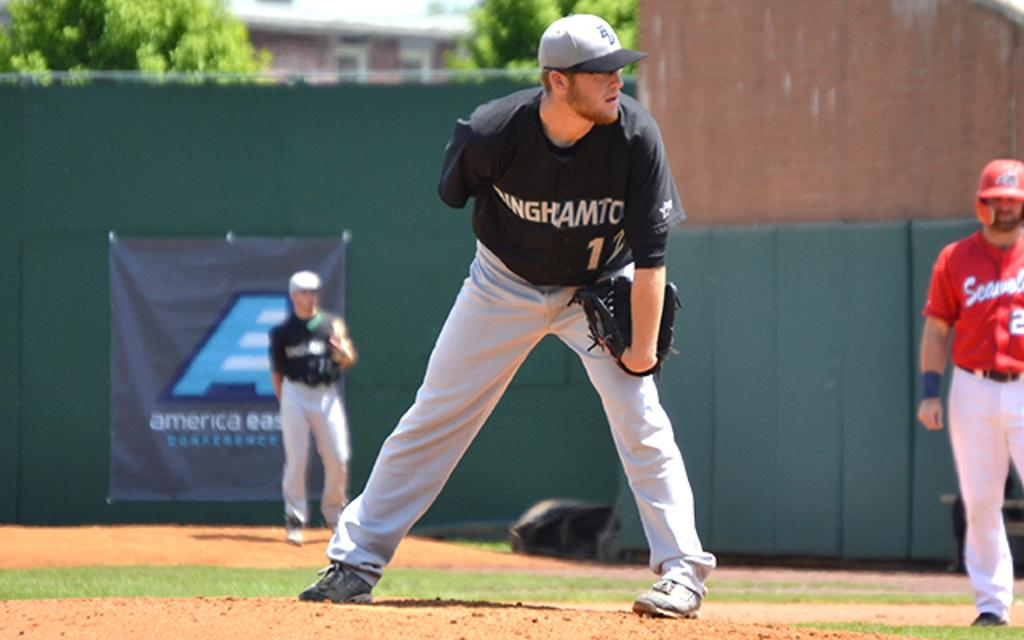<image>
Summarize the visual content of the image. A baseball player in a black #12 jersey stands on the pitchers mound ready to throw. 